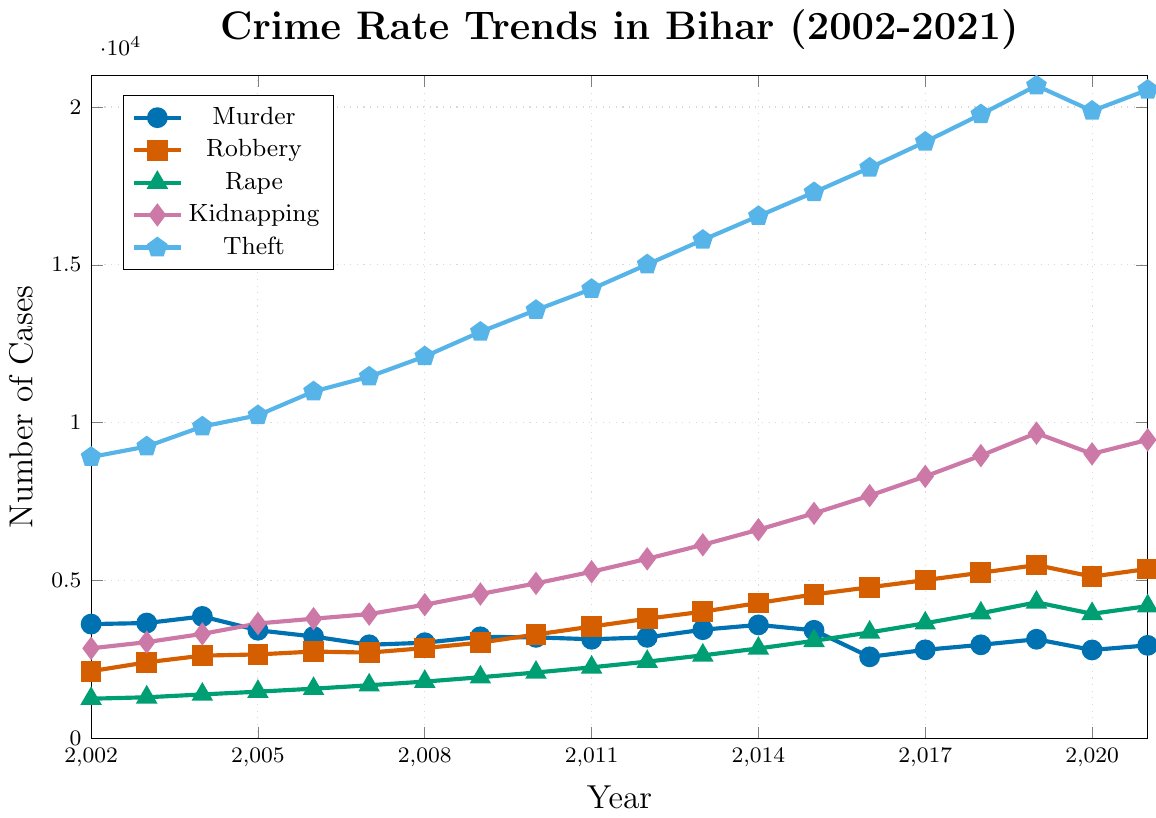What year had the highest number of total reported cases for all offenses combined? To find the year with the highest total number of cases, sum the cases of all offense types for each year. The most significant sum will indicate the year. Summing up the values: 2002: 18763, 2003: 19652, 2004: 21054, 2005: 21231, 2006: 22322, 2007: 22801, 2008: 24016, 2009: 25630, 2010: 26948, 2011: 27938, 2012: 29816, 2013: 31700, 2014: 33678, 2015: 35495, 2016: 36587, 2017: 37442, 2018: 40791, 2019: 43282, 2020: 40755, 2021: 42500. The highest sum is in 2019.
Answer: 2019 Which offense type showed the most consistent increase over the years from 2002 to 2021? Observe the trend lines for each offense type and identify which one shows a consistent upward trend without significant fluctuations. Theft consistently increases every year from 2002 to 2021.
Answer: Theft What is the difference in the number of kidnapping cases between the years 2002 and 2021? Subtract the number of kidnapping cases in 2002 from the number of kidnapping cases in 2021: 9456 (2021) - 2851 (2002) = 6605
Answer: 6605 In which year did the number of murder cases drop to its lowest point? Observe the trend line for murder cases and find the year where it reaches its lowest value. The lowest point is in 2016 with 2581 cases.
Answer: 2016 How did the number of robbery cases change between 2010 and 2012? Compare the values for robbery cases in 2010 and 2012: 2012 cases - 2010 cases = 3789 - 3289 = 500
Answer: Increased by 500 Which years saw a decrease in the number of rape cases compared to the previous year? Examine the trend line for rape cases and find years where the number of cases is less than the previous year. The years with decreases are 2019 to 2020.
Answer: 2020 How many more theft cases were there in 2021 compared to 2002? Subtract the number of theft cases in 2002 from the number of theft cases in 2021: 20543 (2021) - 8912 (2002) = 11631
Answer: 11631 Which offense type had the highest number of cases in 2013? Compare the trend lines for all offense types in 2013 and identify the highest value. Theft had the highest cases with 15789.
Answer: Theft Calculate the average number of rape cases reported from 2010 to 2020. Add the number of rape cases from 2010 to 2020 and divide by the number of years: (2085+2249+2430+2628+2847+3089+3355+3645+3962+4308+3945) / 11 = 31767 / 11 ≈ 2888
Answer: 2888 During which period did kidnapping cases increase the most significantly? Identify the period with the highest increase by comparing year-to-year differences. The most significant increase was from 2013 (6130) to 2014 (6608), an increase of 478 cases.
Answer: 2013 to 2014 